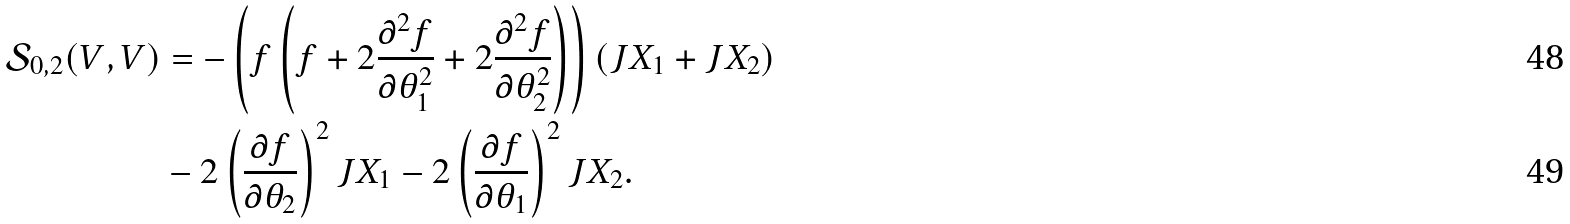<formula> <loc_0><loc_0><loc_500><loc_500>\mathcal { S } _ { 0 , 2 } ( V , V ) & = - \left ( f \left ( f + 2 \frac { \partial ^ { 2 } f } { \partial \theta _ { 1 } ^ { 2 } } + 2 \frac { \partial ^ { 2 } f } { \partial \theta _ { 2 } ^ { 2 } } \right ) \right ) ( J X _ { 1 } + J X _ { 2 } ) \\ & - 2 \left ( \frac { \partial f } { \partial \theta _ { 2 } } \right ) ^ { 2 } J X _ { 1 } - 2 \left ( \frac { \partial f } { \partial \theta _ { 1 } } \right ) ^ { 2 } J X _ { 2 } .</formula> 